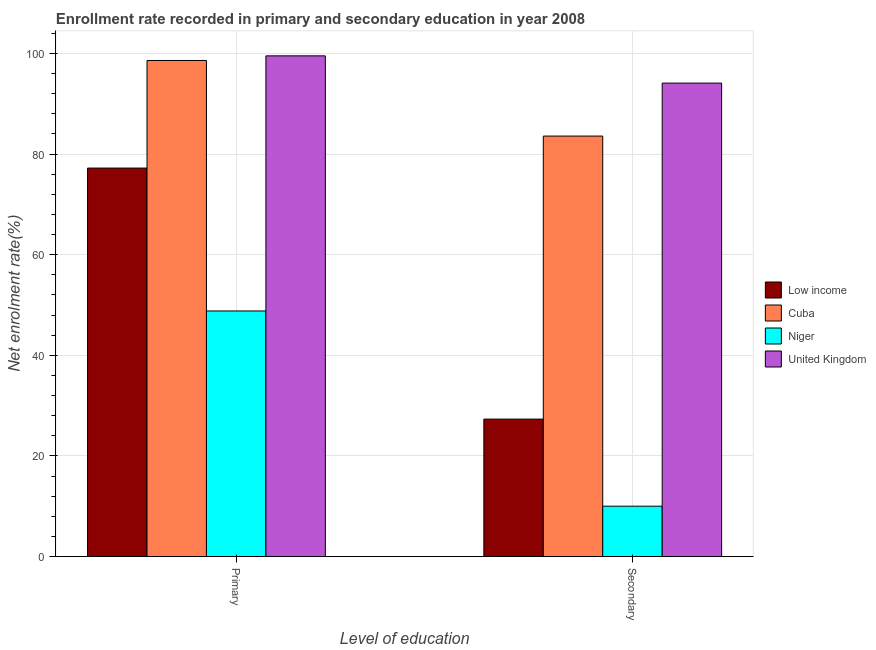How many different coloured bars are there?
Provide a short and direct response. 4. How many groups of bars are there?
Provide a short and direct response. 2. Are the number of bars per tick equal to the number of legend labels?
Your answer should be very brief. Yes. How many bars are there on the 1st tick from the right?
Your answer should be compact. 4. What is the label of the 2nd group of bars from the left?
Ensure brevity in your answer.  Secondary. What is the enrollment rate in secondary education in United Kingdom?
Ensure brevity in your answer.  94.1. Across all countries, what is the maximum enrollment rate in primary education?
Your answer should be compact. 99.51. Across all countries, what is the minimum enrollment rate in secondary education?
Ensure brevity in your answer.  10. In which country was the enrollment rate in secondary education maximum?
Provide a succinct answer. United Kingdom. In which country was the enrollment rate in secondary education minimum?
Offer a terse response. Niger. What is the total enrollment rate in secondary education in the graph?
Ensure brevity in your answer.  214.98. What is the difference between the enrollment rate in secondary education in United Kingdom and that in Cuba?
Keep it short and to the point. 10.53. What is the difference between the enrollment rate in primary education in Low income and the enrollment rate in secondary education in United Kingdom?
Your answer should be compact. -16.89. What is the average enrollment rate in secondary education per country?
Your answer should be compact. 53.75. What is the difference between the enrollment rate in secondary education and enrollment rate in primary education in Niger?
Ensure brevity in your answer.  -38.81. In how many countries, is the enrollment rate in primary education greater than 52 %?
Your response must be concise. 3. What is the ratio of the enrollment rate in secondary education in Low income to that in Cuba?
Ensure brevity in your answer.  0.33. What does the 3rd bar from the left in Primary represents?
Your answer should be compact. Niger. What does the 1st bar from the right in Primary represents?
Keep it short and to the point. United Kingdom. How many bars are there?
Keep it short and to the point. 8. Are all the bars in the graph horizontal?
Keep it short and to the point. No. How many countries are there in the graph?
Give a very brief answer. 4. What is the difference between two consecutive major ticks on the Y-axis?
Provide a short and direct response. 20. Are the values on the major ticks of Y-axis written in scientific E-notation?
Offer a very short reply. No. Does the graph contain any zero values?
Ensure brevity in your answer.  No. Does the graph contain grids?
Your response must be concise. Yes. Where does the legend appear in the graph?
Your answer should be very brief. Center right. How many legend labels are there?
Make the answer very short. 4. What is the title of the graph?
Your response must be concise. Enrollment rate recorded in primary and secondary education in year 2008. Does "United States" appear as one of the legend labels in the graph?
Make the answer very short. No. What is the label or title of the X-axis?
Offer a terse response. Level of education. What is the label or title of the Y-axis?
Give a very brief answer. Net enrolment rate(%). What is the Net enrolment rate(%) of Low income in Primary?
Offer a very short reply. 77.21. What is the Net enrolment rate(%) in Cuba in Primary?
Provide a short and direct response. 98.6. What is the Net enrolment rate(%) of Niger in Primary?
Your answer should be very brief. 48.81. What is the Net enrolment rate(%) of United Kingdom in Primary?
Keep it short and to the point. 99.51. What is the Net enrolment rate(%) of Low income in Secondary?
Keep it short and to the point. 27.31. What is the Net enrolment rate(%) in Cuba in Secondary?
Provide a short and direct response. 83.57. What is the Net enrolment rate(%) of Niger in Secondary?
Offer a terse response. 10. What is the Net enrolment rate(%) in United Kingdom in Secondary?
Ensure brevity in your answer.  94.1. Across all Level of education, what is the maximum Net enrolment rate(%) of Low income?
Offer a very short reply. 77.21. Across all Level of education, what is the maximum Net enrolment rate(%) of Cuba?
Your answer should be very brief. 98.6. Across all Level of education, what is the maximum Net enrolment rate(%) of Niger?
Give a very brief answer. 48.81. Across all Level of education, what is the maximum Net enrolment rate(%) in United Kingdom?
Make the answer very short. 99.51. Across all Level of education, what is the minimum Net enrolment rate(%) in Low income?
Ensure brevity in your answer.  27.31. Across all Level of education, what is the minimum Net enrolment rate(%) of Cuba?
Give a very brief answer. 83.57. Across all Level of education, what is the minimum Net enrolment rate(%) in Niger?
Keep it short and to the point. 10. Across all Level of education, what is the minimum Net enrolment rate(%) in United Kingdom?
Give a very brief answer. 94.1. What is the total Net enrolment rate(%) in Low income in the graph?
Offer a very short reply. 104.52. What is the total Net enrolment rate(%) in Cuba in the graph?
Your answer should be very brief. 182.17. What is the total Net enrolment rate(%) in Niger in the graph?
Provide a short and direct response. 58.81. What is the total Net enrolment rate(%) in United Kingdom in the graph?
Provide a succinct answer. 193.61. What is the difference between the Net enrolment rate(%) in Low income in Primary and that in Secondary?
Your answer should be compact. 49.9. What is the difference between the Net enrolment rate(%) in Cuba in Primary and that in Secondary?
Provide a succinct answer. 15.03. What is the difference between the Net enrolment rate(%) in Niger in Primary and that in Secondary?
Provide a short and direct response. 38.81. What is the difference between the Net enrolment rate(%) in United Kingdom in Primary and that in Secondary?
Offer a very short reply. 5.41. What is the difference between the Net enrolment rate(%) in Low income in Primary and the Net enrolment rate(%) in Cuba in Secondary?
Your response must be concise. -6.36. What is the difference between the Net enrolment rate(%) of Low income in Primary and the Net enrolment rate(%) of Niger in Secondary?
Provide a short and direct response. 67.21. What is the difference between the Net enrolment rate(%) of Low income in Primary and the Net enrolment rate(%) of United Kingdom in Secondary?
Your answer should be compact. -16.89. What is the difference between the Net enrolment rate(%) in Cuba in Primary and the Net enrolment rate(%) in Niger in Secondary?
Your response must be concise. 88.59. What is the difference between the Net enrolment rate(%) of Cuba in Primary and the Net enrolment rate(%) of United Kingdom in Secondary?
Your answer should be very brief. 4.5. What is the difference between the Net enrolment rate(%) in Niger in Primary and the Net enrolment rate(%) in United Kingdom in Secondary?
Make the answer very short. -45.29. What is the average Net enrolment rate(%) of Low income per Level of education?
Offer a very short reply. 52.26. What is the average Net enrolment rate(%) in Cuba per Level of education?
Keep it short and to the point. 91.08. What is the average Net enrolment rate(%) of Niger per Level of education?
Keep it short and to the point. 29.41. What is the average Net enrolment rate(%) in United Kingdom per Level of education?
Ensure brevity in your answer.  96.81. What is the difference between the Net enrolment rate(%) of Low income and Net enrolment rate(%) of Cuba in Primary?
Offer a terse response. -21.39. What is the difference between the Net enrolment rate(%) of Low income and Net enrolment rate(%) of Niger in Primary?
Your answer should be compact. 28.4. What is the difference between the Net enrolment rate(%) of Low income and Net enrolment rate(%) of United Kingdom in Primary?
Your response must be concise. -22.3. What is the difference between the Net enrolment rate(%) in Cuba and Net enrolment rate(%) in Niger in Primary?
Provide a succinct answer. 49.79. What is the difference between the Net enrolment rate(%) in Cuba and Net enrolment rate(%) in United Kingdom in Primary?
Provide a short and direct response. -0.92. What is the difference between the Net enrolment rate(%) of Niger and Net enrolment rate(%) of United Kingdom in Primary?
Offer a terse response. -50.7. What is the difference between the Net enrolment rate(%) of Low income and Net enrolment rate(%) of Cuba in Secondary?
Provide a succinct answer. -56.26. What is the difference between the Net enrolment rate(%) of Low income and Net enrolment rate(%) of Niger in Secondary?
Give a very brief answer. 17.31. What is the difference between the Net enrolment rate(%) in Low income and Net enrolment rate(%) in United Kingdom in Secondary?
Offer a terse response. -66.79. What is the difference between the Net enrolment rate(%) of Cuba and Net enrolment rate(%) of Niger in Secondary?
Give a very brief answer. 73.57. What is the difference between the Net enrolment rate(%) in Cuba and Net enrolment rate(%) in United Kingdom in Secondary?
Your answer should be compact. -10.53. What is the difference between the Net enrolment rate(%) in Niger and Net enrolment rate(%) in United Kingdom in Secondary?
Give a very brief answer. -84.1. What is the ratio of the Net enrolment rate(%) in Low income in Primary to that in Secondary?
Offer a very short reply. 2.83. What is the ratio of the Net enrolment rate(%) of Cuba in Primary to that in Secondary?
Your answer should be very brief. 1.18. What is the ratio of the Net enrolment rate(%) in Niger in Primary to that in Secondary?
Ensure brevity in your answer.  4.88. What is the ratio of the Net enrolment rate(%) in United Kingdom in Primary to that in Secondary?
Your answer should be compact. 1.06. What is the difference between the highest and the second highest Net enrolment rate(%) of Low income?
Keep it short and to the point. 49.9. What is the difference between the highest and the second highest Net enrolment rate(%) of Cuba?
Your answer should be compact. 15.03. What is the difference between the highest and the second highest Net enrolment rate(%) of Niger?
Your answer should be very brief. 38.81. What is the difference between the highest and the second highest Net enrolment rate(%) in United Kingdom?
Offer a very short reply. 5.41. What is the difference between the highest and the lowest Net enrolment rate(%) in Low income?
Keep it short and to the point. 49.9. What is the difference between the highest and the lowest Net enrolment rate(%) of Cuba?
Make the answer very short. 15.03. What is the difference between the highest and the lowest Net enrolment rate(%) in Niger?
Offer a very short reply. 38.81. What is the difference between the highest and the lowest Net enrolment rate(%) in United Kingdom?
Ensure brevity in your answer.  5.41. 